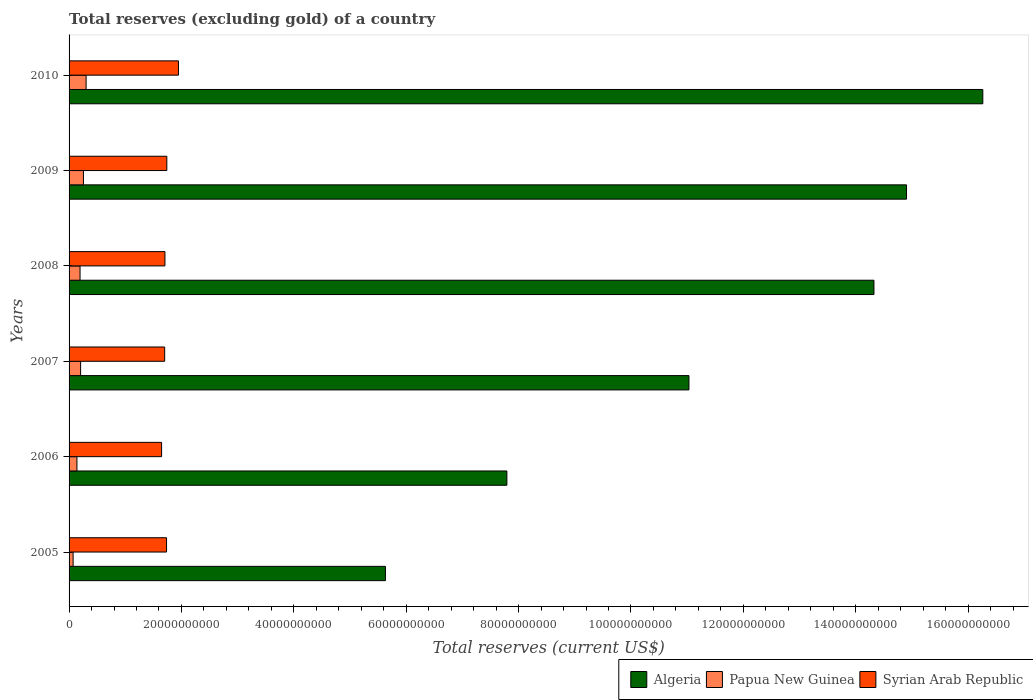How many different coloured bars are there?
Provide a short and direct response. 3. What is the label of the 4th group of bars from the top?
Your response must be concise. 2007. What is the total reserves (excluding gold) in Papua New Guinea in 2006?
Offer a terse response. 1.40e+09. Across all years, what is the maximum total reserves (excluding gold) in Algeria?
Your response must be concise. 1.63e+11. Across all years, what is the minimum total reserves (excluding gold) in Algeria?
Keep it short and to the point. 5.63e+1. What is the total total reserves (excluding gold) in Algeria in the graph?
Give a very brief answer. 6.99e+11. What is the difference between the total reserves (excluding gold) in Syrian Arab Republic in 2005 and that in 2008?
Your answer should be compact. 2.85e+08. What is the difference between the total reserves (excluding gold) in Algeria in 2005 and the total reserves (excluding gold) in Syrian Arab Republic in 2009?
Offer a terse response. 3.89e+1. What is the average total reserves (excluding gold) in Algeria per year?
Ensure brevity in your answer.  1.17e+11. In the year 2008, what is the difference between the total reserves (excluding gold) in Algeria and total reserves (excluding gold) in Syrian Arab Republic?
Your answer should be very brief. 1.26e+11. In how many years, is the total reserves (excluding gold) in Syrian Arab Republic greater than 56000000000 US$?
Give a very brief answer. 0. What is the ratio of the total reserves (excluding gold) in Algeria in 2007 to that in 2010?
Your response must be concise. 0.68. Is the total reserves (excluding gold) in Algeria in 2006 less than that in 2007?
Keep it short and to the point. Yes. What is the difference between the highest and the second highest total reserves (excluding gold) in Papua New Guinea?
Give a very brief answer. 4.72e+08. What is the difference between the highest and the lowest total reserves (excluding gold) in Syrian Arab Republic?
Your answer should be compact. 3.00e+09. Is the sum of the total reserves (excluding gold) in Algeria in 2006 and 2008 greater than the maximum total reserves (excluding gold) in Papua New Guinea across all years?
Your answer should be very brief. Yes. What does the 1st bar from the top in 2009 represents?
Give a very brief answer. Syrian Arab Republic. What does the 1st bar from the bottom in 2005 represents?
Provide a short and direct response. Algeria. Is it the case that in every year, the sum of the total reserves (excluding gold) in Syrian Arab Republic and total reserves (excluding gold) in Algeria is greater than the total reserves (excluding gold) in Papua New Guinea?
Your answer should be very brief. Yes. How many bars are there?
Offer a very short reply. 18. Are the values on the major ticks of X-axis written in scientific E-notation?
Your answer should be compact. No. Does the graph contain grids?
Offer a very short reply. No. How many legend labels are there?
Your answer should be compact. 3. How are the legend labels stacked?
Give a very brief answer. Horizontal. What is the title of the graph?
Your answer should be compact. Total reserves (excluding gold) of a country. What is the label or title of the X-axis?
Your answer should be very brief. Total reserves (current US$). What is the label or title of the Y-axis?
Your response must be concise. Years. What is the Total reserves (current US$) of Algeria in 2005?
Your answer should be very brief. 5.63e+1. What is the Total reserves (current US$) of Papua New Guinea in 2005?
Keep it short and to the point. 7.18e+08. What is the Total reserves (current US$) of Syrian Arab Republic in 2005?
Keep it short and to the point. 1.73e+1. What is the Total reserves (current US$) of Algeria in 2006?
Your answer should be very brief. 7.79e+1. What is the Total reserves (current US$) of Papua New Guinea in 2006?
Give a very brief answer. 1.40e+09. What is the Total reserves (current US$) in Syrian Arab Republic in 2006?
Your response must be concise. 1.65e+1. What is the Total reserves (current US$) of Algeria in 2007?
Your answer should be very brief. 1.10e+11. What is the Total reserves (current US$) of Papua New Guinea in 2007?
Ensure brevity in your answer.  2.05e+09. What is the Total reserves (current US$) of Syrian Arab Republic in 2007?
Offer a terse response. 1.70e+1. What is the Total reserves (current US$) in Algeria in 2008?
Your answer should be very brief. 1.43e+11. What is the Total reserves (current US$) in Papua New Guinea in 2008?
Give a very brief answer. 1.95e+09. What is the Total reserves (current US$) in Syrian Arab Republic in 2008?
Make the answer very short. 1.71e+1. What is the Total reserves (current US$) of Algeria in 2009?
Your response must be concise. 1.49e+11. What is the Total reserves (current US$) in Papua New Guinea in 2009?
Provide a succinct answer. 2.56e+09. What is the Total reserves (current US$) in Syrian Arab Republic in 2009?
Ensure brevity in your answer.  1.74e+1. What is the Total reserves (current US$) of Algeria in 2010?
Provide a succinct answer. 1.63e+11. What is the Total reserves (current US$) of Papua New Guinea in 2010?
Give a very brief answer. 3.03e+09. What is the Total reserves (current US$) in Syrian Arab Republic in 2010?
Provide a succinct answer. 1.95e+1. Across all years, what is the maximum Total reserves (current US$) of Algeria?
Offer a terse response. 1.63e+11. Across all years, what is the maximum Total reserves (current US$) of Papua New Guinea?
Offer a terse response. 3.03e+09. Across all years, what is the maximum Total reserves (current US$) in Syrian Arab Republic?
Your answer should be compact. 1.95e+1. Across all years, what is the minimum Total reserves (current US$) in Algeria?
Keep it short and to the point. 5.63e+1. Across all years, what is the minimum Total reserves (current US$) of Papua New Guinea?
Provide a short and direct response. 7.18e+08. Across all years, what is the minimum Total reserves (current US$) in Syrian Arab Republic?
Provide a short and direct response. 1.65e+1. What is the total Total reserves (current US$) of Algeria in the graph?
Offer a terse response. 6.99e+11. What is the total Total reserves (current US$) in Papua New Guinea in the graph?
Your answer should be compact. 1.17e+1. What is the total Total reserves (current US$) in Syrian Arab Republic in the graph?
Provide a succinct answer. 1.05e+11. What is the difference between the Total reserves (current US$) in Algeria in 2005 and that in 2006?
Your answer should be very brief. -2.16e+1. What is the difference between the Total reserves (current US$) of Papua New Guinea in 2005 and that in 2006?
Offer a terse response. -6.83e+08. What is the difference between the Total reserves (current US$) of Syrian Arab Republic in 2005 and that in 2006?
Provide a succinct answer. 8.79e+08. What is the difference between the Total reserves (current US$) of Algeria in 2005 and that in 2007?
Offer a terse response. -5.40e+1. What is the difference between the Total reserves (current US$) of Papua New Guinea in 2005 and that in 2007?
Ensure brevity in your answer.  -1.34e+09. What is the difference between the Total reserves (current US$) in Syrian Arab Republic in 2005 and that in 2007?
Your answer should be very brief. 3.34e+08. What is the difference between the Total reserves (current US$) of Algeria in 2005 and that in 2008?
Keep it short and to the point. -8.69e+1. What is the difference between the Total reserves (current US$) in Papua New Guinea in 2005 and that in 2008?
Your answer should be compact. -1.24e+09. What is the difference between the Total reserves (current US$) of Syrian Arab Republic in 2005 and that in 2008?
Make the answer very short. 2.85e+08. What is the difference between the Total reserves (current US$) of Algeria in 2005 and that in 2009?
Provide a short and direct response. -9.27e+1. What is the difference between the Total reserves (current US$) of Papua New Guinea in 2005 and that in 2009?
Your response must be concise. -1.84e+09. What is the difference between the Total reserves (current US$) in Syrian Arab Republic in 2005 and that in 2009?
Offer a very short reply. -5.09e+07. What is the difference between the Total reserves (current US$) of Algeria in 2005 and that in 2010?
Make the answer very short. -1.06e+11. What is the difference between the Total reserves (current US$) in Papua New Guinea in 2005 and that in 2010?
Your response must be concise. -2.31e+09. What is the difference between the Total reserves (current US$) in Syrian Arab Republic in 2005 and that in 2010?
Ensure brevity in your answer.  -2.12e+09. What is the difference between the Total reserves (current US$) of Algeria in 2006 and that in 2007?
Offer a very short reply. -3.24e+1. What is the difference between the Total reserves (current US$) of Papua New Guinea in 2006 and that in 2007?
Your answer should be compact. -6.53e+08. What is the difference between the Total reserves (current US$) of Syrian Arab Republic in 2006 and that in 2007?
Your answer should be very brief. -5.46e+08. What is the difference between the Total reserves (current US$) in Algeria in 2006 and that in 2008?
Your answer should be compact. -6.53e+1. What is the difference between the Total reserves (current US$) in Papua New Guinea in 2006 and that in 2008?
Your answer should be compact. -5.53e+08. What is the difference between the Total reserves (current US$) of Syrian Arab Republic in 2006 and that in 2008?
Give a very brief answer. -5.95e+08. What is the difference between the Total reserves (current US$) of Algeria in 2006 and that in 2009?
Your answer should be compact. -7.11e+1. What is the difference between the Total reserves (current US$) of Papua New Guinea in 2006 and that in 2009?
Keep it short and to the point. -1.16e+09. What is the difference between the Total reserves (current US$) in Syrian Arab Republic in 2006 and that in 2009?
Ensure brevity in your answer.  -9.30e+08. What is the difference between the Total reserves (current US$) of Algeria in 2006 and that in 2010?
Your answer should be very brief. -8.47e+1. What is the difference between the Total reserves (current US$) in Papua New Guinea in 2006 and that in 2010?
Ensure brevity in your answer.  -1.63e+09. What is the difference between the Total reserves (current US$) of Syrian Arab Republic in 2006 and that in 2010?
Keep it short and to the point. -3.00e+09. What is the difference between the Total reserves (current US$) in Algeria in 2007 and that in 2008?
Your response must be concise. -3.29e+1. What is the difference between the Total reserves (current US$) of Papua New Guinea in 2007 and that in 2008?
Your answer should be very brief. 1.00e+08. What is the difference between the Total reserves (current US$) of Syrian Arab Republic in 2007 and that in 2008?
Offer a very short reply. -4.89e+07. What is the difference between the Total reserves (current US$) in Algeria in 2007 and that in 2009?
Your response must be concise. -3.87e+1. What is the difference between the Total reserves (current US$) in Papua New Guinea in 2007 and that in 2009?
Offer a terse response. -5.07e+08. What is the difference between the Total reserves (current US$) in Syrian Arab Republic in 2007 and that in 2009?
Offer a very short reply. -3.85e+08. What is the difference between the Total reserves (current US$) in Algeria in 2007 and that in 2010?
Make the answer very short. -5.23e+1. What is the difference between the Total reserves (current US$) in Papua New Guinea in 2007 and that in 2010?
Give a very brief answer. -9.79e+08. What is the difference between the Total reserves (current US$) in Syrian Arab Republic in 2007 and that in 2010?
Keep it short and to the point. -2.45e+09. What is the difference between the Total reserves (current US$) in Algeria in 2008 and that in 2009?
Make the answer very short. -5.80e+09. What is the difference between the Total reserves (current US$) in Papua New Guinea in 2008 and that in 2009?
Offer a very short reply. -6.07e+08. What is the difference between the Total reserves (current US$) in Syrian Arab Republic in 2008 and that in 2009?
Provide a succinct answer. -3.36e+08. What is the difference between the Total reserves (current US$) in Algeria in 2008 and that in 2010?
Provide a short and direct response. -1.94e+1. What is the difference between the Total reserves (current US$) of Papua New Guinea in 2008 and that in 2010?
Ensure brevity in your answer.  -1.08e+09. What is the difference between the Total reserves (current US$) in Syrian Arab Republic in 2008 and that in 2010?
Ensure brevity in your answer.  -2.40e+09. What is the difference between the Total reserves (current US$) of Algeria in 2009 and that in 2010?
Make the answer very short. -1.36e+1. What is the difference between the Total reserves (current US$) in Papua New Guinea in 2009 and that in 2010?
Your response must be concise. -4.72e+08. What is the difference between the Total reserves (current US$) in Syrian Arab Republic in 2009 and that in 2010?
Your response must be concise. -2.07e+09. What is the difference between the Total reserves (current US$) in Algeria in 2005 and the Total reserves (current US$) in Papua New Guinea in 2006?
Make the answer very short. 5.49e+1. What is the difference between the Total reserves (current US$) in Algeria in 2005 and the Total reserves (current US$) in Syrian Arab Republic in 2006?
Offer a terse response. 3.98e+1. What is the difference between the Total reserves (current US$) of Papua New Guinea in 2005 and the Total reserves (current US$) of Syrian Arab Republic in 2006?
Ensure brevity in your answer.  -1.57e+1. What is the difference between the Total reserves (current US$) of Algeria in 2005 and the Total reserves (current US$) of Papua New Guinea in 2007?
Offer a very short reply. 5.42e+1. What is the difference between the Total reserves (current US$) in Algeria in 2005 and the Total reserves (current US$) in Syrian Arab Republic in 2007?
Provide a short and direct response. 3.93e+1. What is the difference between the Total reserves (current US$) in Papua New Guinea in 2005 and the Total reserves (current US$) in Syrian Arab Republic in 2007?
Provide a short and direct response. -1.63e+1. What is the difference between the Total reserves (current US$) of Algeria in 2005 and the Total reserves (current US$) of Papua New Guinea in 2008?
Offer a very short reply. 5.43e+1. What is the difference between the Total reserves (current US$) of Algeria in 2005 and the Total reserves (current US$) of Syrian Arab Republic in 2008?
Offer a terse response. 3.92e+1. What is the difference between the Total reserves (current US$) in Papua New Guinea in 2005 and the Total reserves (current US$) in Syrian Arab Republic in 2008?
Your response must be concise. -1.63e+1. What is the difference between the Total reserves (current US$) of Algeria in 2005 and the Total reserves (current US$) of Papua New Guinea in 2009?
Your answer should be compact. 5.37e+1. What is the difference between the Total reserves (current US$) in Algeria in 2005 and the Total reserves (current US$) in Syrian Arab Republic in 2009?
Provide a short and direct response. 3.89e+1. What is the difference between the Total reserves (current US$) of Papua New Guinea in 2005 and the Total reserves (current US$) of Syrian Arab Republic in 2009?
Your answer should be very brief. -1.67e+1. What is the difference between the Total reserves (current US$) of Algeria in 2005 and the Total reserves (current US$) of Papua New Guinea in 2010?
Provide a short and direct response. 5.33e+1. What is the difference between the Total reserves (current US$) of Algeria in 2005 and the Total reserves (current US$) of Syrian Arab Republic in 2010?
Your response must be concise. 3.68e+1. What is the difference between the Total reserves (current US$) of Papua New Guinea in 2005 and the Total reserves (current US$) of Syrian Arab Republic in 2010?
Keep it short and to the point. -1.87e+1. What is the difference between the Total reserves (current US$) in Algeria in 2006 and the Total reserves (current US$) in Papua New Guinea in 2007?
Keep it short and to the point. 7.59e+1. What is the difference between the Total reserves (current US$) in Algeria in 2006 and the Total reserves (current US$) in Syrian Arab Republic in 2007?
Your answer should be compact. 6.09e+1. What is the difference between the Total reserves (current US$) of Papua New Guinea in 2006 and the Total reserves (current US$) of Syrian Arab Republic in 2007?
Your answer should be compact. -1.56e+1. What is the difference between the Total reserves (current US$) in Algeria in 2006 and the Total reserves (current US$) in Papua New Guinea in 2008?
Your answer should be compact. 7.60e+1. What is the difference between the Total reserves (current US$) in Algeria in 2006 and the Total reserves (current US$) in Syrian Arab Republic in 2008?
Provide a succinct answer. 6.09e+1. What is the difference between the Total reserves (current US$) of Papua New Guinea in 2006 and the Total reserves (current US$) of Syrian Arab Republic in 2008?
Your answer should be compact. -1.57e+1. What is the difference between the Total reserves (current US$) of Algeria in 2006 and the Total reserves (current US$) of Papua New Guinea in 2009?
Offer a very short reply. 7.54e+1. What is the difference between the Total reserves (current US$) in Algeria in 2006 and the Total reserves (current US$) in Syrian Arab Republic in 2009?
Make the answer very short. 6.05e+1. What is the difference between the Total reserves (current US$) in Papua New Guinea in 2006 and the Total reserves (current US$) in Syrian Arab Republic in 2009?
Offer a terse response. -1.60e+1. What is the difference between the Total reserves (current US$) of Algeria in 2006 and the Total reserves (current US$) of Papua New Guinea in 2010?
Give a very brief answer. 7.49e+1. What is the difference between the Total reserves (current US$) of Algeria in 2006 and the Total reserves (current US$) of Syrian Arab Republic in 2010?
Give a very brief answer. 5.84e+1. What is the difference between the Total reserves (current US$) in Papua New Guinea in 2006 and the Total reserves (current US$) in Syrian Arab Republic in 2010?
Make the answer very short. -1.81e+1. What is the difference between the Total reserves (current US$) in Algeria in 2007 and the Total reserves (current US$) in Papua New Guinea in 2008?
Your answer should be very brief. 1.08e+11. What is the difference between the Total reserves (current US$) of Algeria in 2007 and the Total reserves (current US$) of Syrian Arab Republic in 2008?
Keep it short and to the point. 9.33e+1. What is the difference between the Total reserves (current US$) in Papua New Guinea in 2007 and the Total reserves (current US$) in Syrian Arab Republic in 2008?
Your answer should be compact. -1.50e+1. What is the difference between the Total reserves (current US$) of Algeria in 2007 and the Total reserves (current US$) of Papua New Guinea in 2009?
Make the answer very short. 1.08e+11. What is the difference between the Total reserves (current US$) in Algeria in 2007 and the Total reserves (current US$) in Syrian Arab Republic in 2009?
Keep it short and to the point. 9.29e+1. What is the difference between the Total reserves (current US$) in Papua New Guinea in 2007 and the Total reserves (current US$) in Syrian Arab Republic in 2009?
Your answer should be very brief. -1.53e+1. What is the difference between the Total reserves (current US$) in Algeria in 2007 and the Total reserves (current US$) in Papua New Guinea in 2010?
Offer a very short reply. 1.07e+11. What is the difference between the Total reserves (current US$) in Algeria in 2007 and the Total reserves (current US$) in Syrian Arab Republic in 2010?
Keep it short and to the point. 9.09e+1. What is the difference between the Total reserves (current US$) in Papua New Guinea in 2007 and the Total reserves (current US$) in Syrian Arab Republic in 2010?
Offer a terse response. -1.74e+1. What is the difference between the Total reserves (current US$) in Algeria in 2008 and the Total reserves (current US$) in Papua New Guinea in 2009?
Provide a short and direct response. 1.41e+11. What is the difference between the Total reserves (current US$) in Algeria in 2008 and the Total reserves (current US$) in Syrian Arab Republic in 2009?
Provide a short and direct response. 1.26e+11. What is the difference between the Total reserves (current US$) of Papua New Guinea in 2008 and the Total reserves (current US$) of Syrian Arab Republic in 2009?
Offer a very short reply. -1.54e+1. What is the difference between the Total reserves (current US$) in Algeria in 2008 and the Total reserves (current US$) in Papua New Guinea in 2010?
Provide a short and direct response. 1.40e+11. What is the difference between the Total reserves (current US$) of Algeria in 2008 and the Total reserves (current US$) of Syrian Arab Republic in 2010?
Give a very brief answer. 1.24e+11. What is the difference between the Total reserves (current US$) of Papua New Guinea in 2008 and the Total reserves (current US$) of Syrian Arab Republic in 2010?
Offer a terse response. -1.75e+1. What is the difference between the Total reserves (current US$) of Algeria in 2009 and the Total reserves (current US$) of Papua New Guinea in 2010?
Make the answer very short. 1.46e+11. What is the difference between the Total reserves (current US$) in Algeria in 2009 and the Total reserves (current US$) in Syrian Arab Republic in 2010?
Your answer should be compact. 1.30e+11. What is the difference between the Total reserves (current US$) of Papua New Guinea in 2009 and the Total reserves (current US$) of Syrian Arab Republic in 2010?
Your answer should be very brief. -1.69e+1. What is the average Total reserves (current US$) in Algeria per year?
Make the answer very short. 1.17e+11. What is the average Total reserves (current US$) in Papua New Guinea per year?
Provide a short and direct response. 1.95e+09. What is the average Total reserves (current US$) in Syrian Arab Republic per year?
Provide a succinct answer. 1.75e+1. In the year 2005, what is the difference between the Total reserves (current US$) in Algeria and Total reserves (current US$) in Papua New Guinea?
Provide a succinct answer. 5.56e+1. In the year 2005, what is the difference between the Total reserves (current US$) of Algeria and Total reserves (current US$) of Syrian Arab Republic?
Provide a short and direct response. 3.90e+1. In the year 2005, what is the difference between the Total reserves (current US$) of Papua New Guinea and Total reserves (current US$) of Syrian Arab Republic?
Your response must be concise. -1.66e+1. In the year 2006, what is the difference between the Total reserves (current US$) in Algeria and Total reserves (current US$) in Papua New Guinea?
Your answer should be very brief. 7.65e+1. In the year 2006, what is the difference between the Total reserves (current US$) of Algeria and Total reserves (current US$) of Syrian Arab Republic?
Offer a very short reply. 6.14e+1. In the year 2006, what is the difference between the Total reserves (current US$) of Papua New Guinea and Total reserves (current US$) of Syrian Arab Republic?
Offer a terse response. -1.51e+1. In the year 2007, what is the difference between the Total reserves (current US$) in Algeria and Total reserves (current US$) in Papua New Guinea?
Give a very brief answer. 1.08e+11. In the year 2007, what is the difference between the Total reserves (current US$) in Algeria and Total reserves (current US$) in Syrian Arab Republic?
Your answer should be compact. 9.33e+1. In the year 2007, what is the difference between the Total reserves (current US$) of Papua New Guinea and Total reserves (current US$) of Syrian Arab Republic?
Give a very brief answer. -1.50e+1. In the year 2008, what is the difference between the Total reserves (current US$) of Algeria and Total reserves (current US$) of Papua New Guinea?
Provide a succinct answer. 1.41e+11. In the year 2008, what is the difference between the Total reserves (current US$) in Algeria and Total reserves (current US$) in Syrian Arab Republic?
Provide a short and direct response. 1.26e+11. In the year 2008, what is the difference between the Total reserves (current US$) in Papua New Guinea and Total reserves (current US$) in Syrian Arab Republic?
Your response must be concise. -1.51e+1. In the year 2009, what is the difference between the Total reserves (current US$) of Algeria and Total reserves (current US$) of Papua New Guinea?
Your answer should be very brief. 1.46e+11. In the year 2009, what is the difference between the Total reserves (current US$) of Algeria and Total reserves (current US$) of Syrian Arab Republic?
Your answer should be compact. 1.32e+11. In the year 2009, what is the difference between the Total reserves (current US$) in Papua New Guinea and Total reserves (current US$) in Syrian Arab Republic?
Provide a short and direct response. -1.48e+1. In the year 2010, what is the difference between the Total reserves (current US$) in Algeria and Total reserves (current US$) in Papua New Guinea?
Give a very brief answer. 1.60e+11. In the year 2010, what is the difference between the Total reserves (current US$) of Algeria and Total reserves (current US$) of Syrian Arab Republic?
Your answer should be compact. 1.43e+11. In the year 2010, what is the difference between the Total reserves (current US$) in Papua New Guinea and Total reserves (current US$) in Syrian Arab Republic?
Provide a succinct answer. -1.64e+1. What is the ratio of the Total reserves (current US$) of Algeria in 2005 to that in 2006?
Your answer should be compact. 0.72. What is the ratio of the Total reserves (current US$) of Papua New Guinea in 2005 to that in 2006?
Give a very brief answer. 0.51. What is the ratio of the Total reserves (current US$) of Syrian Arab Republic in 2005 to that in 2006?
Ensure brevity in your answer.  1.05. What is the ratio of the Total reserves (current US$) in Algeria in 2005 to that in 2007?
Offer a terse response. 0.51. What is the ratio of the Total reserves (current US$) of Papua New Guinea in 2005 to that in 2007?
Make the answer very short. 0.35. What is the ratio of the Total reserves (current US$) in Syrian Arab Republic in 2005 to that in 2007?
Your answer should be compact. 1.02. What is the ratio of the Total reserves (current US$) in Algeria in 2005 to that in 2008?
Your response must be concise. 0.39. What is the ratio of the Total reserves (current US$) of Papua New Guinea in 2005 to that in 2008?
Your answer should be compact. 0.37. What is the ratio of the Total reserves (current US$) in Syrian Arab Republic in 2005 to that in 2008?
Offer a terse response. 1.02. What is the ratio of the Total reserves (current US$) in Algeria in 2005 to that in 2009?
Provide a succinct answer. 0.38. What is the ratio of the Total reserves (current US$) in Papua New Guinea in 2005 to that in 2009?
Your answer should be very brief. 0.28. What is the ratio of the Total reserves (current US$) in Algeria in 2005 to that in 2010?
Offer a very short reply. 0.35. What is the ratio of the Total reserves (current US$) of Papua New Guinea in 2005 to that in 2010?
Make the answer very short. 0.24. What is the ratio of the Total reserves (current US$) of Syrian Arab Republic in 2005 to that in 2010?
Your response must be concise. 0.89. What is the ratio of the Total reserves (current US$) in Algeria in 2006 to that in 2007?
Offer a very short reply. 0.71. What is the ratio of the Total reserves (current US$) in Papua New Guinea in 2006 to that in 2007?
Offer a very short reply. 0.68. What is the ratio of the Total reserves (current US$) of Syrian Arab Republic in 2006 to that in 2007?
Your answer should be compact. 0.97. What is the ratio of the Total reserves (current US$) of Algeria in 2006 to that in 2008?
Provide a short and direct response. 0.54. What is the ratio of the Total reserves (current US$) in Papua New Guinea in 2006 to that in 2008?
Your answer should be very brief. 0.72. What is the ratio of the Total reserves (current US$) in Syrian Arab Republic in 2006 to that in 2008?
Provide a short and direct response. 0.97. What is the ratio of the Total reserves (current US$) of Algeria in 2006 to that in 2009?
Keep it short and to the point. 0.52. What is the ratio of the Total reserves (current US$) in Papua New Guinea in 2006 to that in 2009?
Keep it short and to the point. 0.55. What is the ratio of the Total reserves (current US$) in Syrian Arab Republic in 2006 to that in 2009?
Provide a succinct answer. 0.95. What is the ratio of the Total reserves (current US$) in Algeria in 2006 to that in 2010?
Keep it short and to the point. 0.48. What is the ratio of the Total reserves (current US$) of Papua New Guinea in 2006 to that in 2010?
Make the answer very short. 0.46. What is the ratio of the Total reserves (current US$) in Syrian Arab Republic in 2006 to that in 2010?
Make the answer very short. 0.85. What is the ratio of the Total reserves (current US$) of Algeria in 2007 to that in 2008?
Ensure brevity in your answer.  0.77. What is the ratio of the Total reserves (current US$) of Papua New Guinea in 2007 to that in 2008?
Your answer should be very brief. 1.05. What is the ratio of the Total reserves (current US$) of Syrian Arab Republic in 2007 to that in 2008?
Provide a short and direct response. 1. What is the ratio of the Total reserves (current US$) of Algeria in 2007 to that in 2009?
Make the answer very short. 0.74. What is the ratio of the Total reserves (current US$) in Papua New Guinea in 2007 to that in 2009?
Your answer should be very brief. 0.8. What is the ratio of the Total reserves (current US$) of Syrian Arab Republic in 2007 to that in 2009?
Make the answer very short. 0.98. What is the ratio of the Total reserves (current US$) in Algeria in 2007 to that in 2010?
Your answer should be very brief. 0.68. What is the ratio of the Total reserves (current US$) of Papua New Guinea in 2007 to that in 2010?
Give a very brief answer. 0.68. What is the ratio of the Total reserves (current US$) of Syrian Arab Republic in 2007 to that in 2010?
Your answer should be compact. 0.87. What is the ratio of the Total reserves (current US$) in Algeria in 2008 to that in 2009?
Provide a short and direct response. 0.96. What is the ratio of the Total reserves (current US$) in Papua New Guinea in 2008 to that in 2009?
Provide a short and direct response. 0.76. What is the ratio of the Total reserves (current US$) of Syrian Arab Republic in 2008 to that in 2009?
Offer a very short reply. 0.98. What is the ratio of the Total reserves (current US$) in Algeria in 2008 to that in 2010?
Give a very brief answer. 0.88. What is the ratio of the Total reserves (current US$) of Papua New Guinea in 2008 to that in 2010?
Your answer should be compact. 0.64. What is the ratio of the Total reserves (current US$) in Syrian Arab Republic in 2008 to that in 2010?
Provide a short and direct response. 0.88. What is the ratio of the Total reserves (current US$) in Algeria in 2009 to that in 2010?
Your answer should be compact. 0.92. What is the ratio of the Total reserves (current US$) of Papua New Guinea in 2009 to that in 2010?
Your response must be concise. 0.84. What is the ratio of the Total reserves (current US$) in Syrian Arab Republic in 2009 to that in 2010?
Your response must be concise. 0.89. What is the difference between the highest and the second highest Total reserves (current US$) of Algeria?
Your answer should be very brief. 1.36e+1. What is the difference between the highest and the second highest Total reserves (current US$) in Papua New Guinea?
Offer a very short reply. 4.72e+08. What is the difference between the highest and the second highest Total reserves (current US$) of Syrian Arab Republic?
Provide a succinct answer. 2.07e+09. What is the difference between the highest and the lowest Total reserves (current US$) in Algeria?
Offer a terse response. 1.06e+11. What is the difference between the highest and the lowest Total reserves (current US$) of Papua New Guinea?
Your answer should be compact. 2.31e+09. What is the difference between the highest and the lowest Total reserves (current US$) in Syrian Arab Republic?
Ensure brevity in your answer.  3.00e+09. 